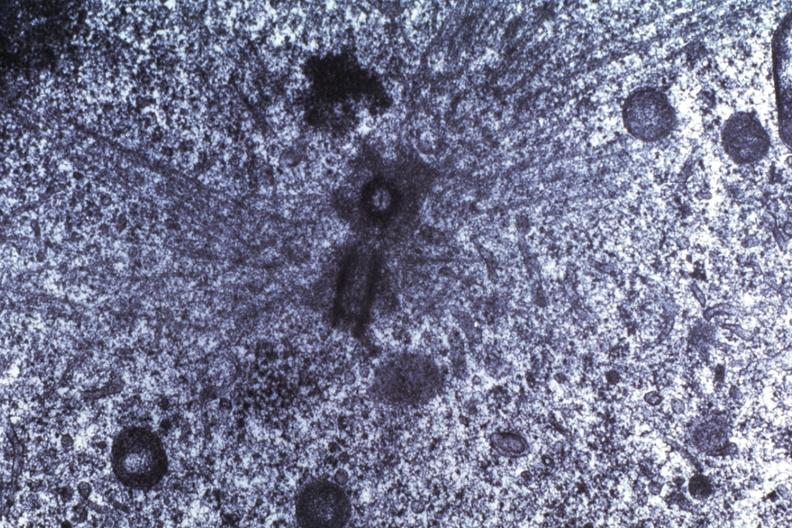does frontal slab of liver show basal body dr garcia tumors 66?
Answer the question using a single word or phrase. No 